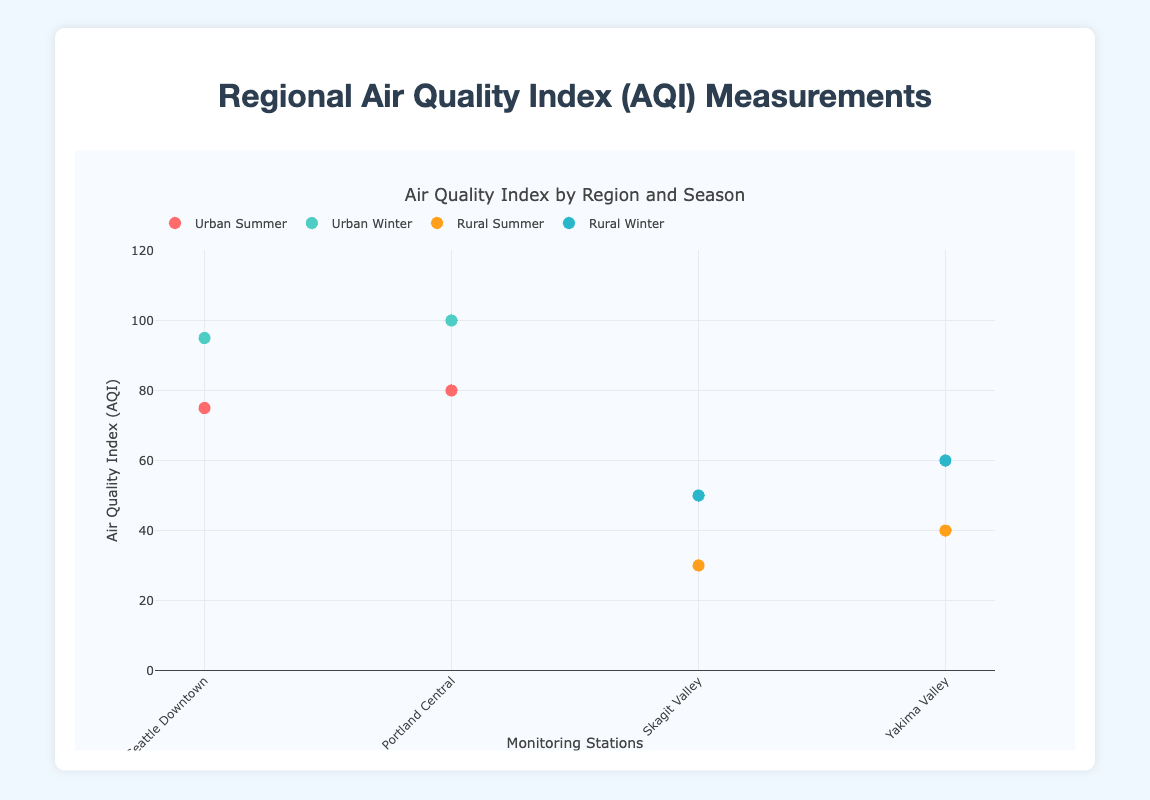What is the title of the figure? The title is displayed at the top of the figure. It reads "Air Quality Index by Region and Season".
Answer: Air Quality Index by Region and Season How many monitoring stations are there in urban areas during the summer season? By looking at the "Urban Summer" markers, we see there are two points (Seattle Downtown and Portland Central).
Answer: 2 Which rural station has the highest AQI in the winter season? By examining the "Rural Winter" markers, Yakima Valley has the higher AQI (60), compared to Skagit Valley (50).
Answer: Yakima Valley Compare the AQI of Seattle Downtown in summer and winter. Which season has a higher AQI? Seattle Downtown in winter has an AQI of 95, which is higher than the summer AQI of 75.
Answer: Winter What is the average AQI of the rural stations in the summer? The rural summer AQI values are 30 and 40. The average is (30 + 40) / 2 = 35.
Answer: 35 By how much does the AQI change between summer and winter at Portland Central? The AQI in summer is 80 and in winter is 100. The change is 100 - 80 = 20.
Answer: 20 Which urban station has the lower AQI in the summer season? Comparing the "Urban Summer" markers: Seattle Downtown has an AQI of 75, and Portland Central has an AQI of 80. Thus, Seattle Downtown has the lower AQI.
Answer: Seattle Downtown Is the AQI generally higher in urban or rural areas during the winter season? In the winter, the AQIs for urban areas are 95 (Seattle Downtown) and 100 (Portland Central) while for rural areas, they are 50 (Skagit Valley) and 60 (Yakima Valley). Urban areas generally have higher AQIs.
Answer: Urban Which season has the highest variation in AQI among the rural stations? In the summer, AQI ranges from 30 (Skagit Valley) to 40 (Yakima Valley), a difference of 10. In the winter, AQI ranges from 50 (Skagit Valley) to 60 (Yakima Valley), also a difference of 10. Both seasons have the same variation.
Answer: Both How much does the AQI increase from summer to winter for Skagit Valley? The AQI in summer is 30 and in winter is 50. The increase is 50 - 30 = 20.
Answer: 20 